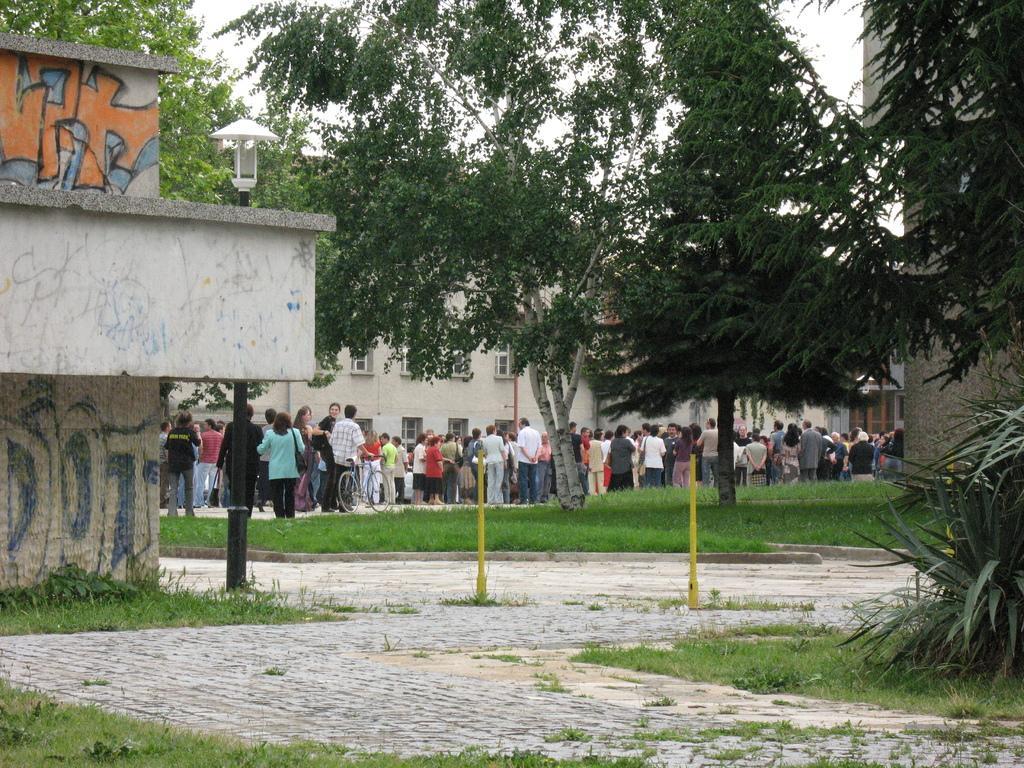Describe this image in one or two sentences. On the left side, there's grass on the ground. On the right side, there is grass on the road and there are plants and grass on the ground. In the background, there are poles, there are trees, buildings, persons on the road and there are clouds in the sky. 